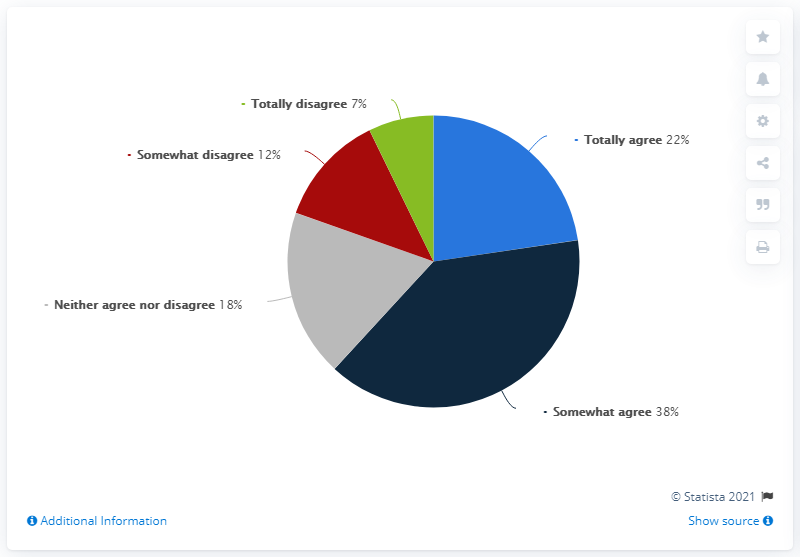What is the average of totally agree and somewhat agree? To calculate the average of 'totally agree' and 'somewhat agree' responses based on the pie chart, we take the sum of the two percentages (22% for 'totally agree' and 38% for 'somewhat agree') and divide by 2. The average percentage is therefore (22% + 38%) / 2, which equals 30%. 